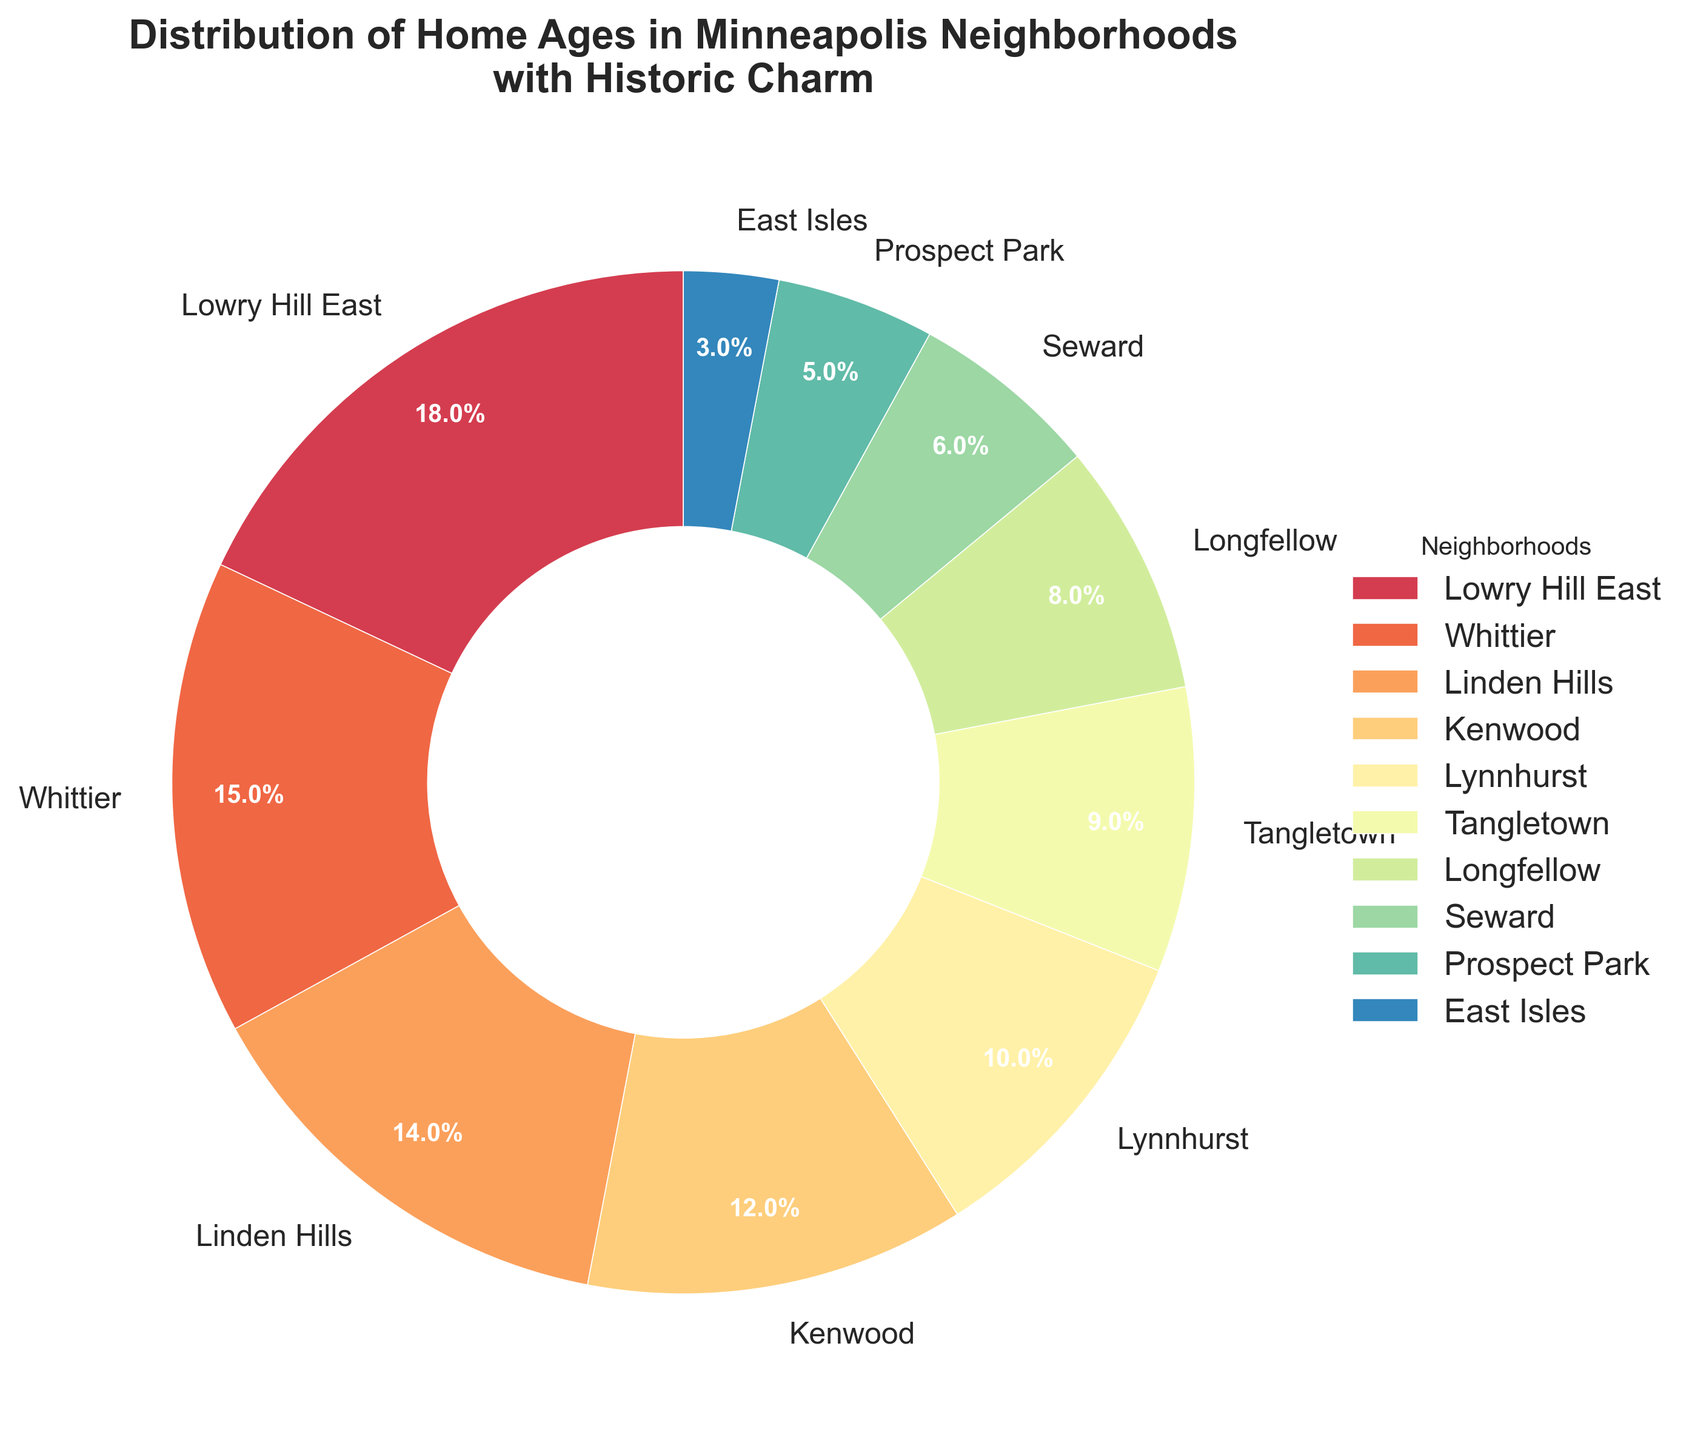Which neighborhood has the highest percentage of homes with historic charm? The neighborhood with the largest slice in the pie chart and highest percentage label is Lowry Hill East.
Answer: Lowry Hill East Which neighborhood has the lowest percentage of historic homes? The neighborhood with the smallest slice in the pie chart and lowest percentage label is East Isles.
Answer: East Isles How much more percentage does Lowry Hill East have compared to Tangletown? Lowry Hill East has 18%, and Tangletown has 9%. The difference is calculated as 18% - 9% = 9%.
Answer: 9% Which two neighborhoods together make up nearly one-third of the distribution? Adding percentages of neighborhoods until reaching close to 33%, Lowry Hill East (18%) + Whittier (15%) = 33%.
Answer: Lowry Hill East and Whittier What is the total percentage of homes in Longfellow, Seward, and Prospect Park? Adding the percentages of these neighborhoods: Longfellow (8%) + Seward (6%) + Prospect Park (5%) = 19%.
Answer: 19% Is there any neighborhood with less than 5% historic homes? By examining the percentage labels, East Isles has 3%, which is less than 5%.
Answer: Yes Which neighborhood has 12% of the homes with historic charm? The neighborhood with the label showing 12% is Kenwood.
Answer: Kenwood How does the percentage of historic homes in Longfellow compare to Seward? Longfellow has 8% while Seward has 6%. Since 8% is greater than 6%, Longfellow has a higher percentage.
Answer: Longfellow has a higher percentage If combining all neighborhoods with a percentage of less than 10%, what is their total percentage? Adding percentages under 10%: Tangletown (9%) + Longfellow (8%) + Seward (6%) + Prospect Park (5%) + East Isles (3%) = 31%.
Answer: 31% What percentage of homes do Linden Hills and Lynnhurst together represent? Adding the percentages of these neighborhoods: Linden Hills (14%) + Lynnhurst (10%) = 24%.
Answer: 24% 